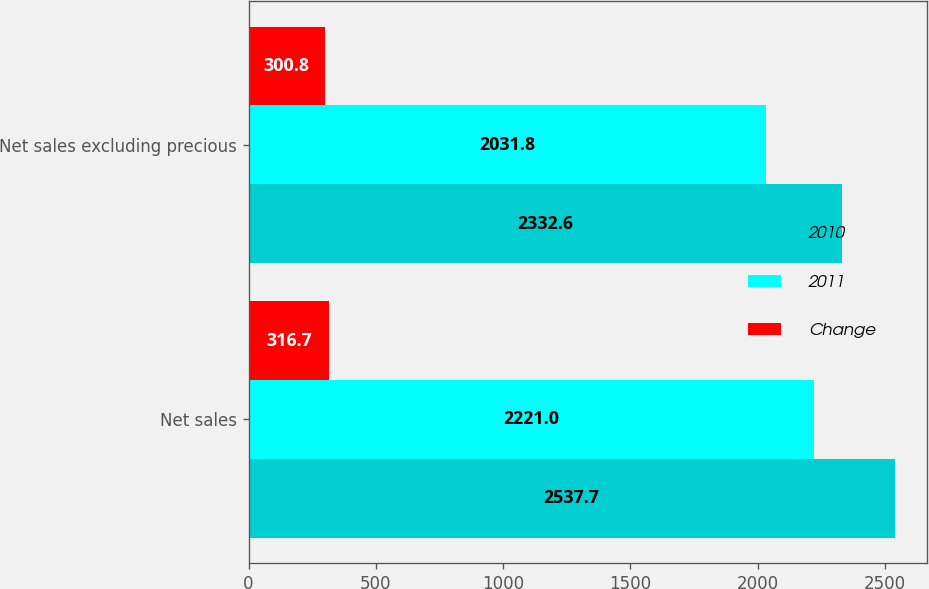Convert chart to OTSL. <chart><loc_0><loc_0><loc_500><loc_500><stacked_bar_chart><ecel><fcel>Net sales<fcel>Net sales excluding precious<nl><fcel>2010<fcel>2537.7<fcel>2332.6<nl><fcel>2011<fcel>2221<fcel>2031.8<nl><fcel>Change<fcel>316.7<fcel>300.8<nl></chart> 